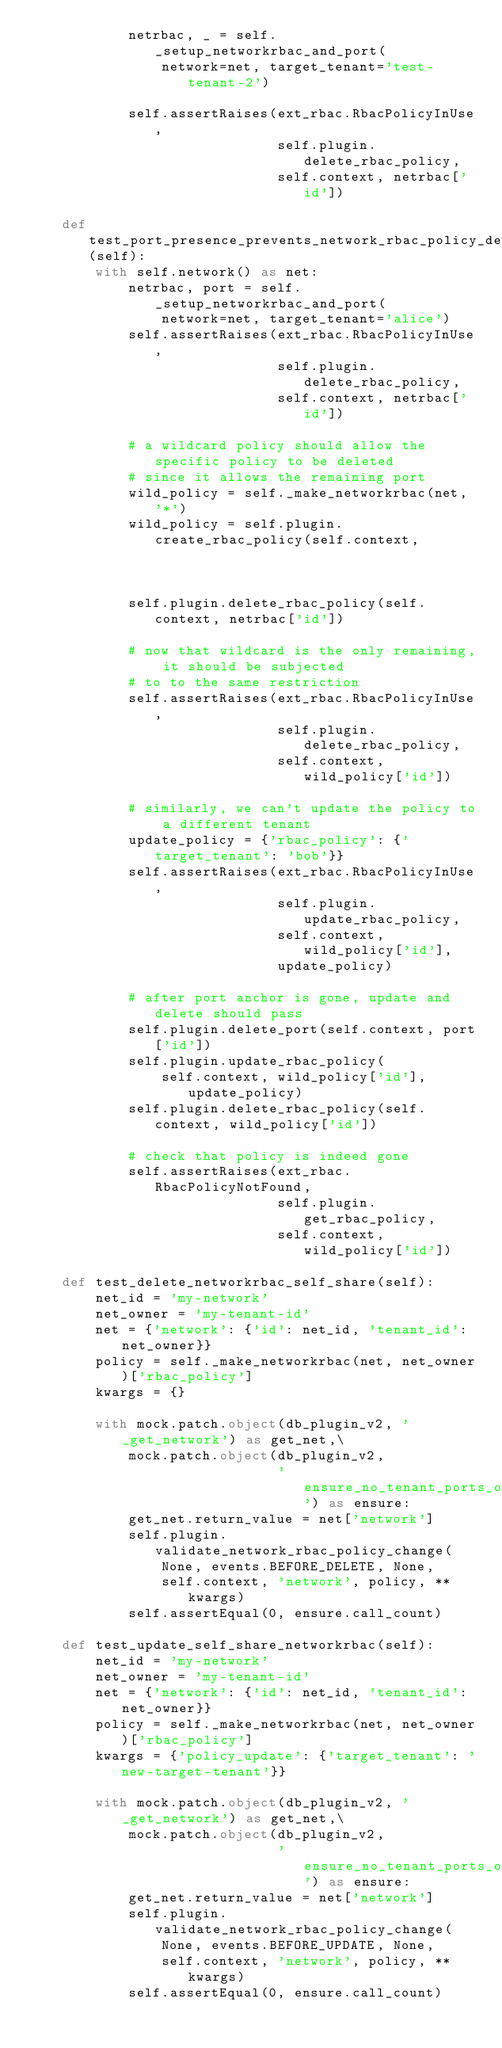<code> <loc_0><loc_0><loc_500><loc_500><_Python_>            netrbac, _ = self._setup_networkrbac_and_port(
                network=net, target_tenant='test-tenant-2')

            self.assertRaises(ext_rbac.RbacPolicyInUse,
                              self.plugin.delete_rbac_policy,
                              self.context, netrbac['id'])

    def test_port_presence_prevents_network_rbac_policy_deletion(self):
        with self.network() as net:
            netrbac, port = self._setup_networkrbac_and_port(
                network=net, target_tenant='alice')
            self.assertRaises(ext_rbac.RbacPolicyInUse,
                              self.plugin.delete_rbac_policy,
                              self.context, netrbac['id'])

            # a wildcard policy should allow the specific policy to be deleted
            # since it allows the remaining port
            wild_policy = self._make_networkrbac(net, '*')
            wild_policy = self.plugin.create_rbac_policy(self.context,
                                                         wild_policy)
            self.plugin.delete_rbac_policy(self.context, netrbac['id'])

            # now that wildcard is the only remaining, it should be subjected
            # to to the same restriction
            self.assertRaises(ext_rbac.RbacPolicyInUse,
                              self.plugin.delete_rbac_policy,
                              self.context, wild_policy['id'])

            # similarly, we can't update the policy to a different tenant
            update_policy = {'rbac_policy': {'target_tenant': 'bob'}}
            self.assertRaises(ext_rbac.RbacPolicyInUse,
                              self.plugin.update_rbac_policy,
                              self.context, wild_policy['id'],
                              update_policy)

            # after port anchor is gone, update and delete should pass
            self.plugin.delete_port(self.context, port['id'])
            self.plugin.update_rbac_policy(
                self.context, wild_policy['id'], update_policy)
            self.plugin.delete_rbac_policy(self.context, wild_policy['id'])

            # check that policy is indeed gone
            self.assertRaises(ext_rbac.RbacPolicyNotFound,
                              self.plugin.get_rbac_policy,
                              self.context, wild_policy['id'])

    def test_delete_networkrbac_self_share(self):
        net_id = 'my-network'
        net_owner = 'my-tenant-id'
        net = {'network': {'id': net_id, 'tenant_id': net_owner}}
        policy = self._make_networkrbac(net, net_owner)['rbac_policy']
        kwargs = {}

        with mock.patch.object(db_plugin_v2, '_get_network') as get_net,\
            mock.patch.object(db_plugin_v2,
                              'ensure_no_tenant_ports_on_network') as ensure:
            get_net.return_value = net['network']
            self.plugin.validate_network_rbac_policy_change(
                None, events.BEFORE_DELETE, None,
                self.context, 'network', policy, **kwargs)
            self.assertEqual(0, ensure.call_count)

    def test_update_self_share_networkrbac(self):
        net_id = 'my-network'
        net_owner = 'my-tenant-id'
        net = {'network': {'id': net_id, 'tenant_id': net_owner}}
        policy = self._make_networkrbac(net, net_owner)['rbac_policy']
        kwargs = {'policy_update': {'target_tenant': 'new-target-tenant'}}

        with mock.patch.object(db_plugin_v2, '_get_network') as get_net,\
            mock.patch.object(db_plugin_v2,
                              'ensure_no_tenant_ports_on_network') as ensure:
            get_net.return_value = net['network']
            self.plugin.validate_network_rbac_policy_change(
                None, events.BEFORE_UPDATE, None,
                self.context, 'network', policy, **kwargs)
            self.assertEqual(0, ensure.call_count)
</code> 